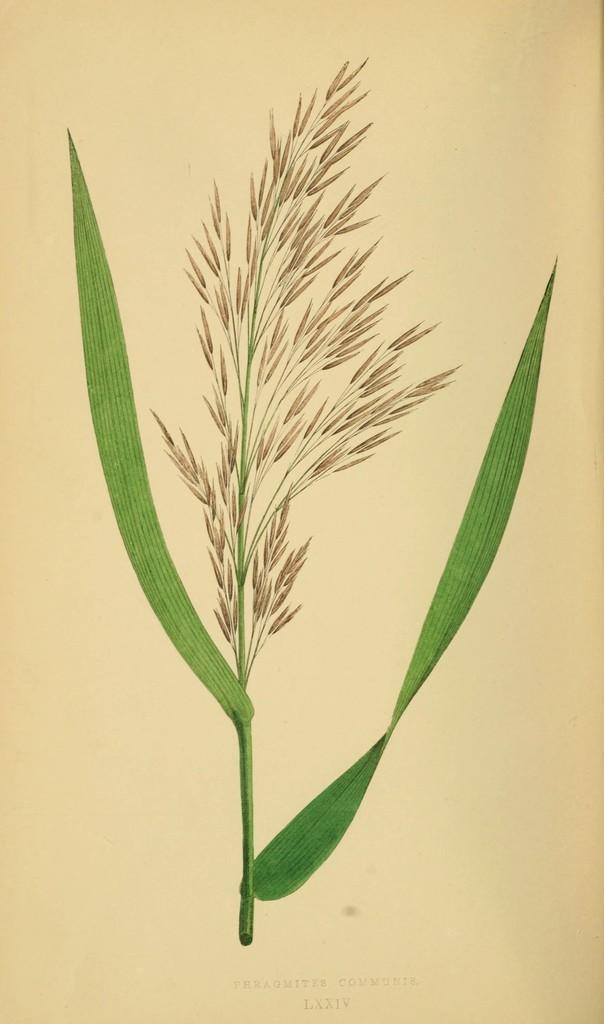Can you describe this image briefly? This is a picture of a plant. We can see green leaves. At the bottom we can see there is something written. 